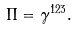Convert formula to latex. <formula><loc_0><loc_0><loc_500><loc_500>\Pi = \gamma ^ { 1 2 3 } .</formula> 